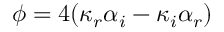Convert formula to latex. <formula><loc_0><loc_0><loc_500><loc_500>\phi = 4 ( \kappa _ { r } \alpha _ { i } - \kappa _ { i } \alpha _ { r } )</formula> 